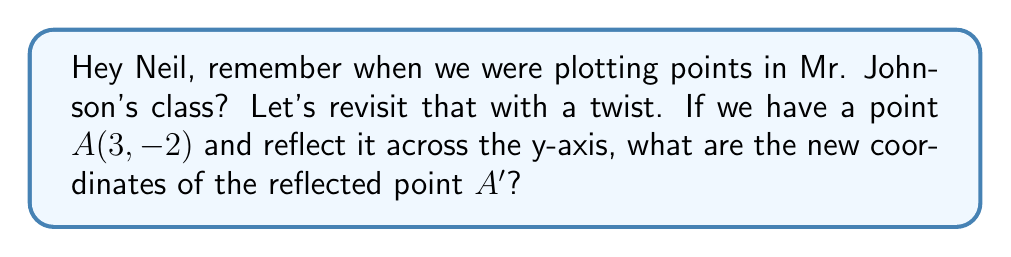Teach me how to tackle this problem. Let's approach this step-by-step:

1) When we reflect a point across the y-axis, the y-coordinate remains the same, but the x-coordinate changes sign.

2) For a point $(x, y)$, its reflection across the y-axis is $(-x, y)$.

3) In our case, we have the point $A(3, -2)$:
   - The x-coordinate is 3
   - The y-coordinate is -2

4) To reflect this point:
   - The new x-coordinate will be $-(3) = -3$
   - The y-coordinate stays as -2

5) Therefore, the coordinates of the reflected point $A'$ are $(-3, -2)$.

[asy]
unitsize(1cm);
draw((-4,0)--(4,0),arrow=Arrow());
draw((0,-3)--(0,3),arrow=Arrow());
dot((3,-2),red);
dot((-3,-2),blue);
label("A(3, -2)",(3,-2),E,red);
label("A'(-3, -2)",(-3,-2),W,blue);
label("x",(4,0),E);
label("y",(0,3),N);
[/asy]
Answer: $A'(-3, -2)$ 